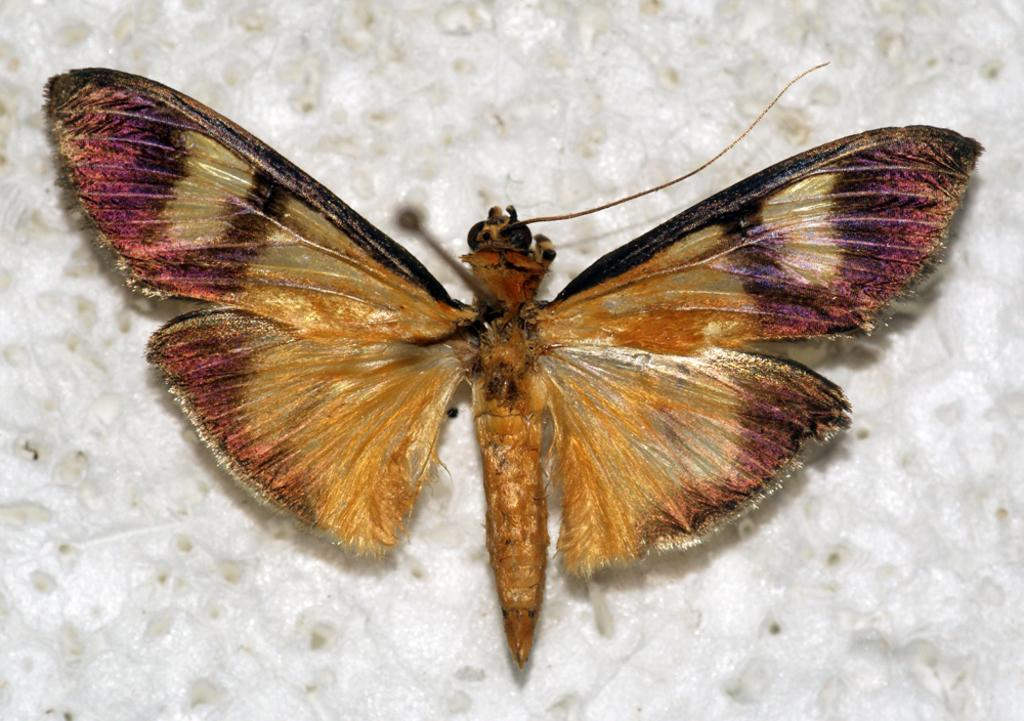What is the color of the surface in the image? The surface in the image is white. What type of creature is on the surface? There is a golden and purple insect on the surface. Is the insect stuck in quicksand on the white surface? There is no quicksand present in the image, and the insect is not depicted as being stuck. What type of parent might the insect have in the image? There is no indication of the insect's parent in the image, as it is not mentioned or depicted. 